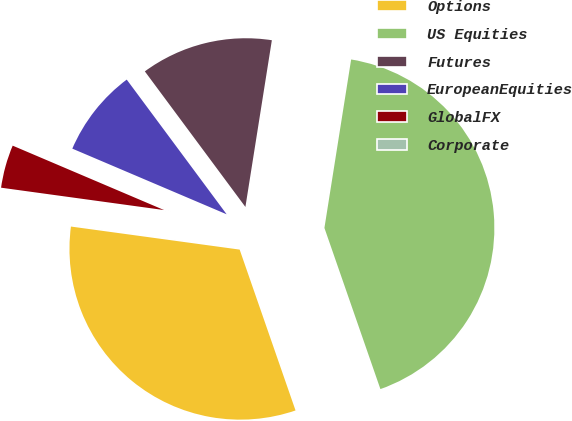Convert chart to OTSL. <chart><loc_0><loc_0><loc_500><loc_500><pie_chart><fcel>Options<fcel>US Equities<fcel>Futures<fcel>EuropeanEquities<fcel>GlobalFX<fcel>Corporate<nl><fcel>32.48%<fcel>42.17%<fcel>12.66%<fcel>8.44%<fcel>4.23%<fcel>0.01%<nl></chart> 